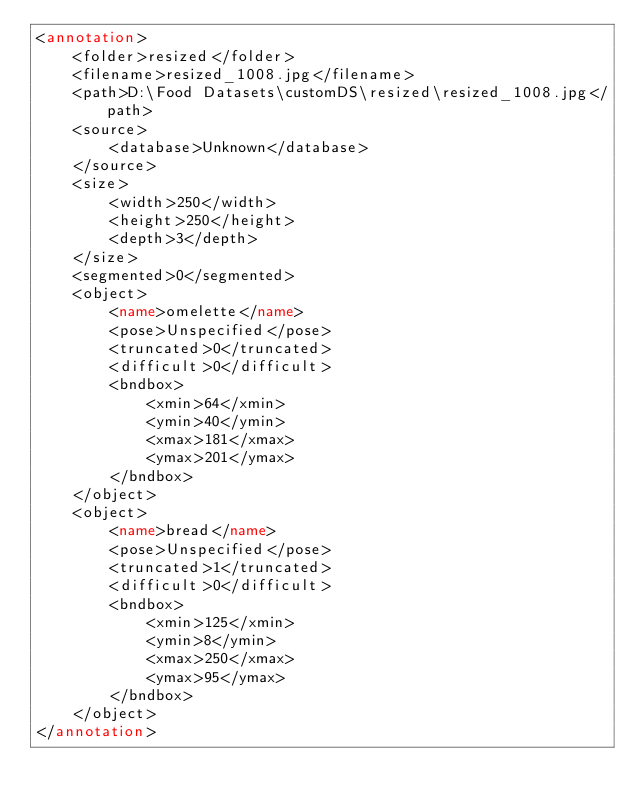<code> <loc_0><loc_0><loc_500><loc_500><_XML_><annotation>
	<folder>resized</folder>
	<filename>resized_1008.jpg</filename>
	<path>D:\Food Datasets\customDS\resized\resized_1008.jpg</path>
	<source>
		<database>Unknown</database>
	</source>
	<size>
		<width>250</width>
		<height>250</height>
		<depth>3</depth>
	</size>
	<segmented>0</segmented>
	<object>
		<name>omelette</name>
		<pose>Unspecified</pose>
		<truncated>0</truncated>
		<difficult>0</difficult>
		<bndbox>
			<xmin>64</xmin>
			<ymin>40</ymin>
			<xmax>181</xmax>
			<ymax>201</ymax>
		</bndbox>
	</object>
	<object>
		<name>bread</name>
		<pose>Unspecified</pose>
		<truncated>1</truncated>
		<difficult>0</difficult>
		<bndbox>
			<xmin>125</xmin>
			<ymin>8</ymin>
			<xmax>250</xmax>
			<ymax>95</ymax>
		</bndbox>
	</object>
</annotation>
</code> 